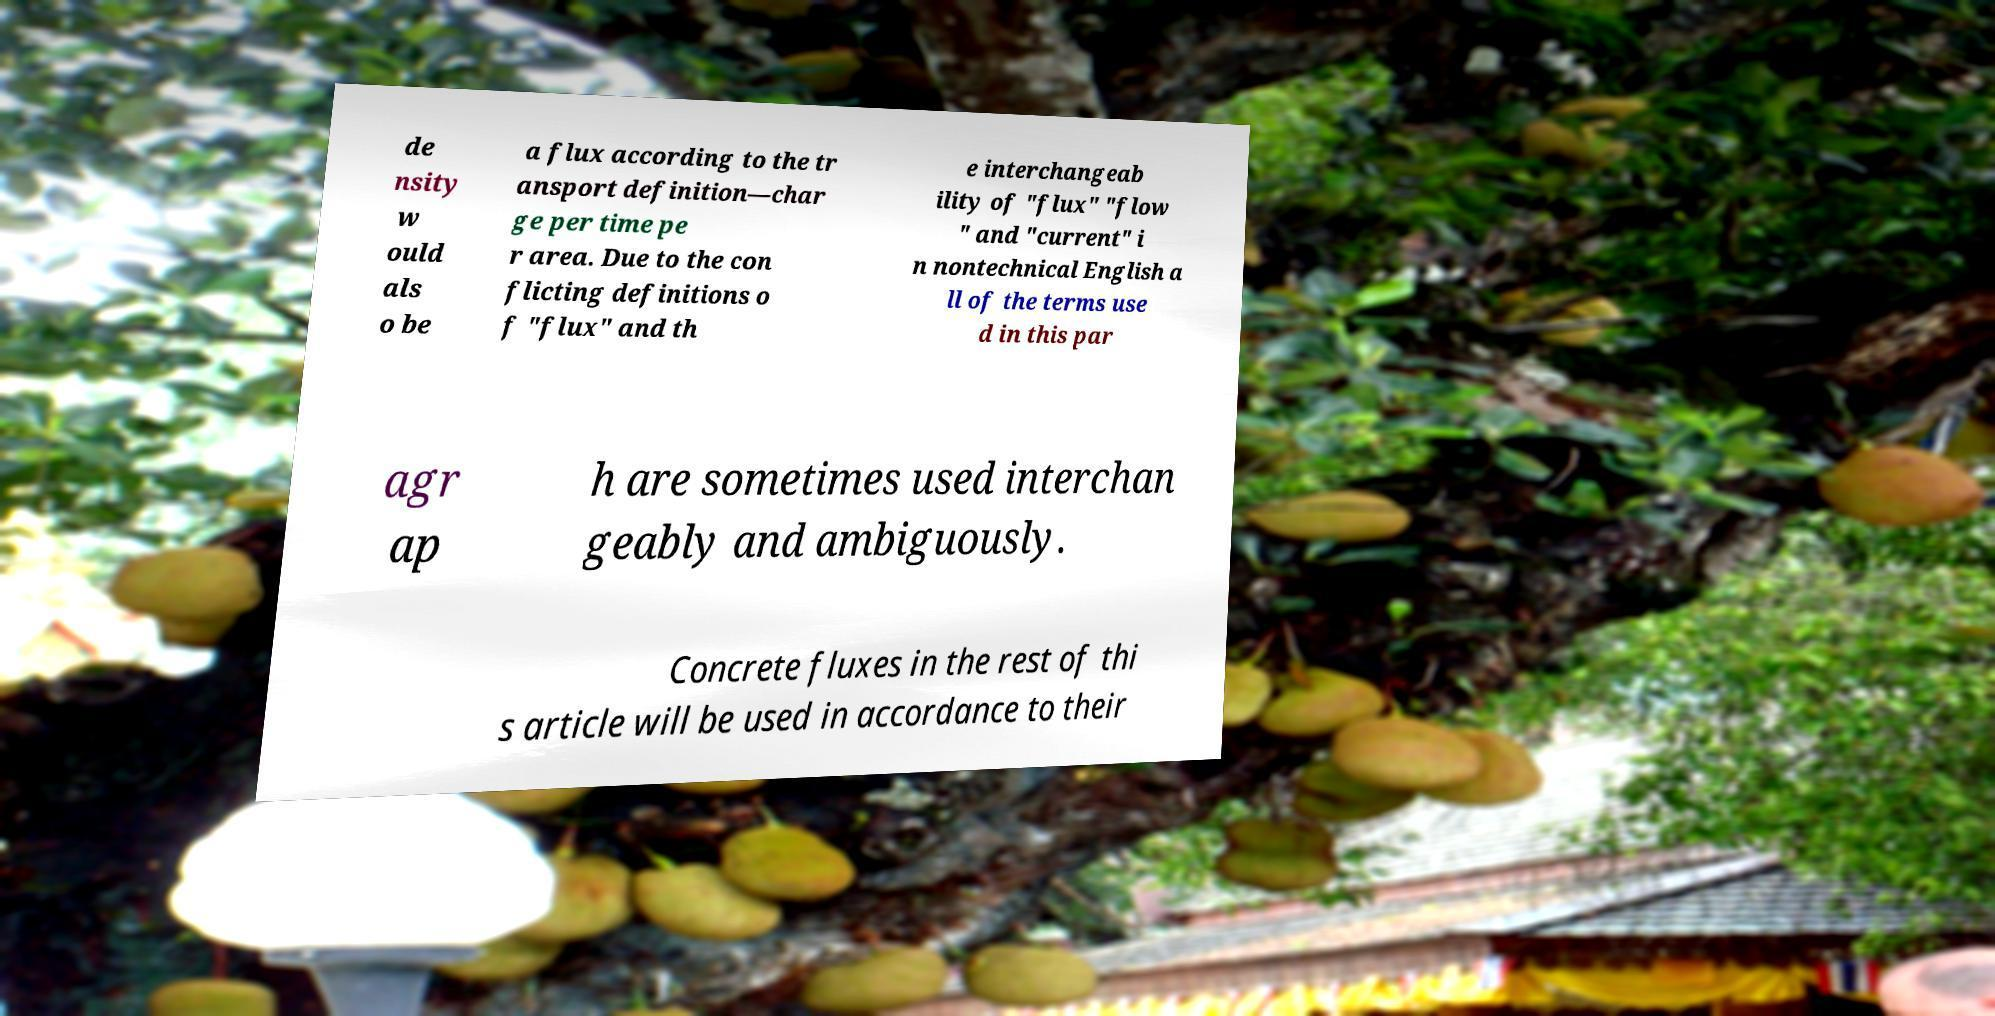Can you read and provide the text displayed in the image?This photo seems to have some interesting text. Can you extract and type it out for me? de nsity w ould als o be a flux according to the tr ansport definition—char ge per time pe r area. Due to the con flicting definitions o f "flux" and th e interchangeab ility of "flux" "flow " and "current" i n nontechnical English a ll of the terms use d in this par agr ap h are sometimes used interchan geably and ambiguously. Concrete fluxes in the rest of thi s article will be used in accordance to their 